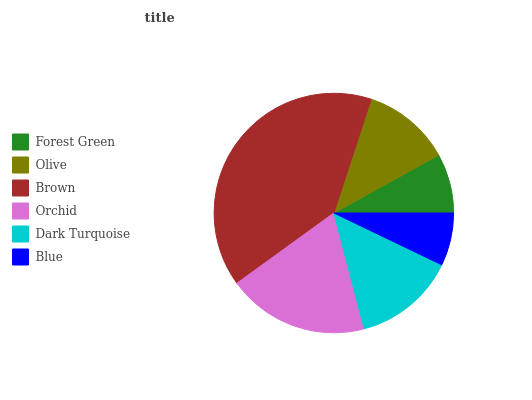Is Blue the minimum?
Answer yes or no. Yes. Is Brown the maximum?
Answer yes or no. Yes. Is Olive the minimum?
Answer yes or no. No. Is Olive the maximum?
Answer yes or no. No. Is Olive greater than Forest Green?
Answer yes or no. Yes. Is Forest Green less than Olive?
Answer yes or no. Yes. Is Forest Green greater than Olive?
Answer yes or no. No. Is Olive less than Forest Green?
Answer yes or no. No. Is Dark Turquoise the high median?
Answer yes or no. Yes. Is Olive the low median?
Answer yes or no. Yes. Is Orchid the high median?
Answer yes or no. No. Is Brown the low median?
Answer yes or no. No. 